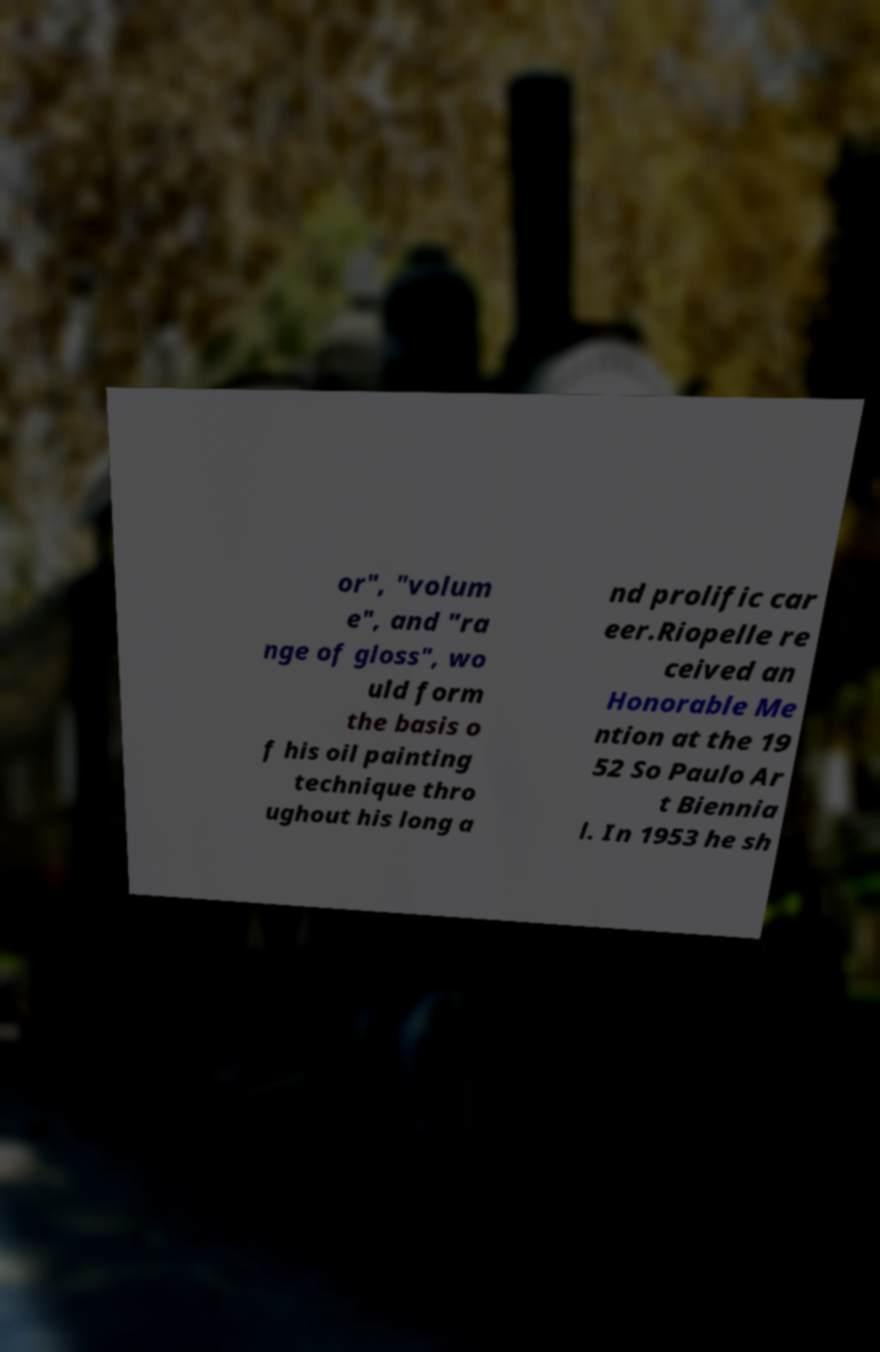What messages or text are displayed in this image? I need them in a readable, typed format. or", "volum e", and "ra nge of gloss", wo uld form the basis o f his oil painting technique thro ughout his long a nd prolific car eer.Riopelle re ceived an Honorable Me ntion at the 19 52 So Paulo Ar t Biennia l. In 1953 he sh 